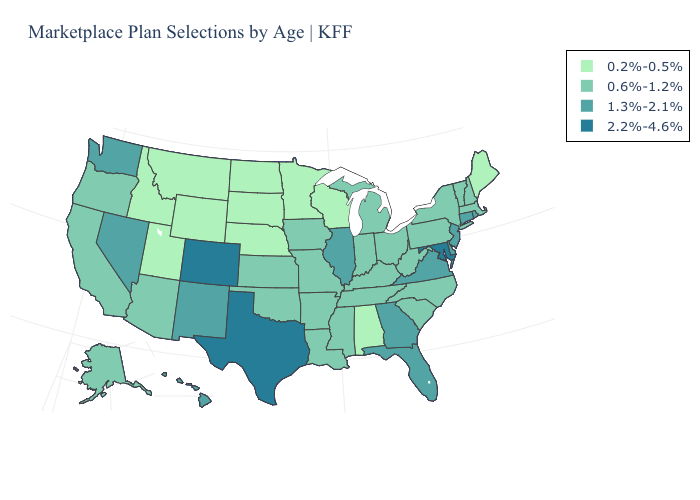Does the map have missing data?
Be succinct. No. How many symbols are there in the legend?
Quick response, please. 4. Does South Dakota have the lowest value in the USA?
Write a very short answer. Yes. Does North Dakota have the same value as Nebraska?
Quick response, please. Yes. Which states have the lowest value in the West?
Short answer required. Idaho, Montana, Utah, Wyoming. Name the states that have a value in the range 0.2%-0.5%?
Answer briefly. Alabama, Idaho, Maine, Minnesota, Montana, Nebraska, North Dakota, South Dakota, Utah, Wisconsin, Wyoming. Does Nevada have the lowest value in the USA?
Quick response, please. No. What is the value of Ohio?
Give a very brief answer. 0.6%-1.2%. Does Tennessee have the highest value in the South?
Be succinct. No. Does the first symbol in the legend represent the smallest category?
Answer briefly. Yes. How many symbols are there in the legend?
Keep it brief. 4. What is the value of Maryland?
Concise answer only. 2.2%-4.6%. What is the value of Wisconsin?
Write a very short answer. 0.2%-0.5%. Name the states that have a value in the range 1.3%-2.1%?
Answer briefly. Connecticut, Delaware, Florida, Georgia, Hawaii, Illinois, Nevada, New Jersey, New Mexico, Rhode Island, Virginia, Washington. Which states have the lowest value in the West?
Answer briefly. Idaho, Montana, Utah, Wyoming. 